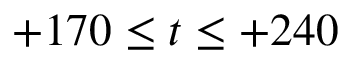Convert formula to latex. <formula><loc_0><loc_0><loc_500><loc_500>+ 1 7 0 \leq t \leq + 2 4 0</formula> 